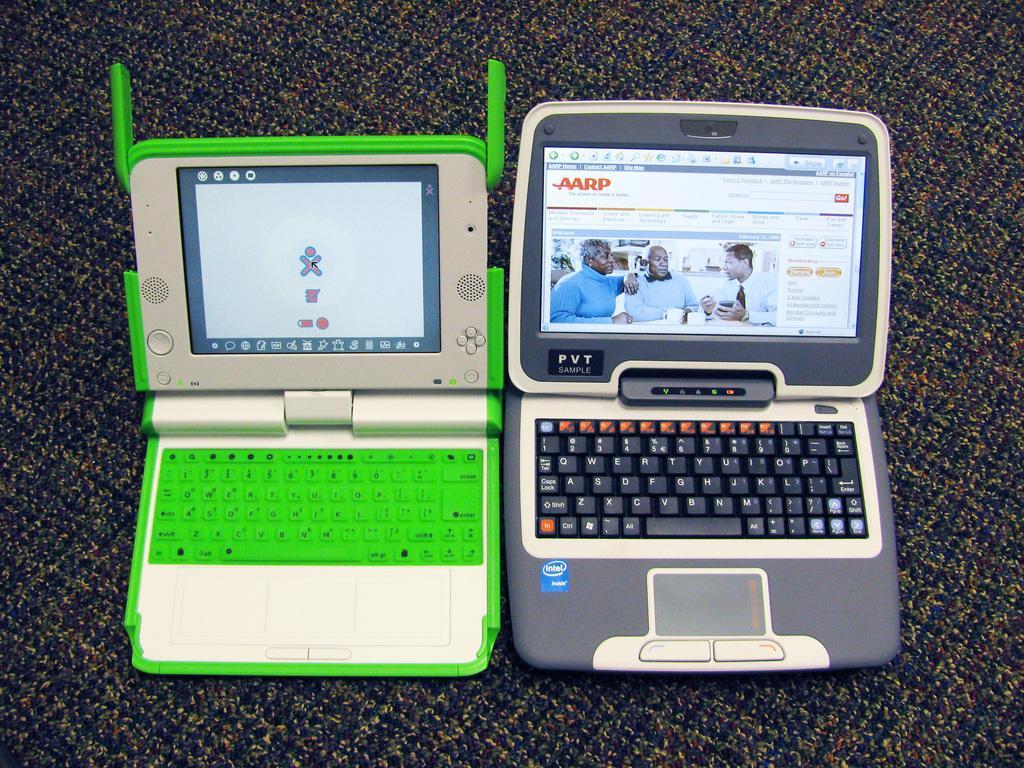Can you describe this image briefly? In this picture there are two devices. On the screen of the device there are group of people and there is a text. There are keyboards on the device. At the bottom there is a mat. 